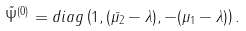Convert formula to latex. <formula><loc_0><loc_0><loc_500><loc_500>\tilde { \Psi } ^ { ( 0 ) } = d i a g \left ( 1 , ( \bar { \mu _ { 2 } } - \lambda ) , - ( \mu _ { 1 } - \lambda ) \right ) .</formula> 